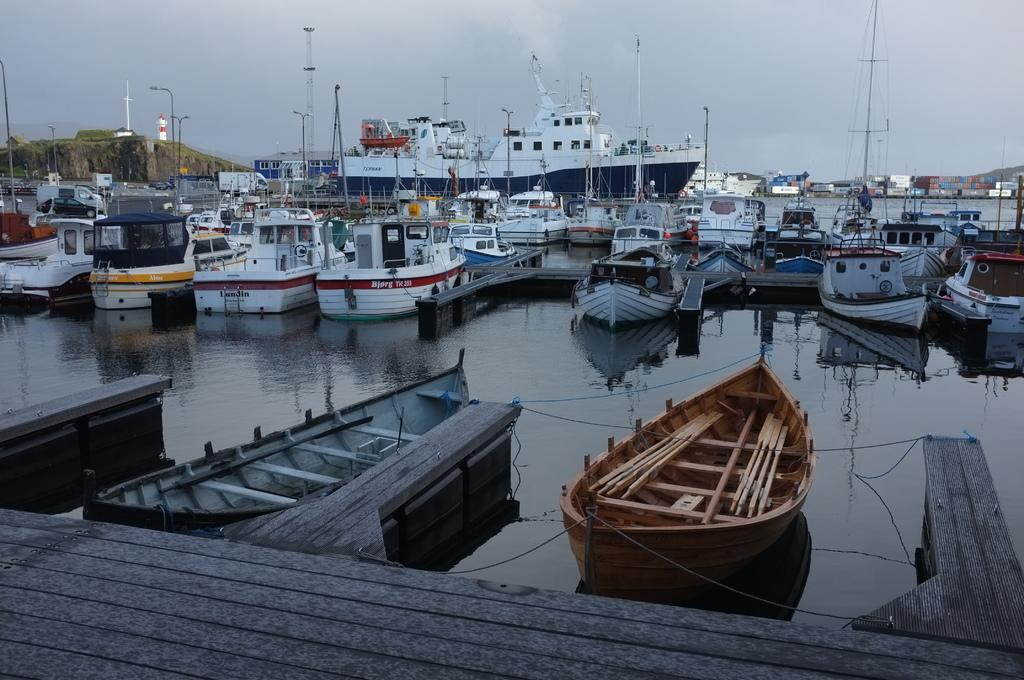What types of watercraft are visible in the image? There are ships and boats in the image. Where are the ships and boats located? They are on the surface of water in the image. What is the condition of the sky in the image? The sky is covered with clouds. What is at the bottom of the image? There is a wooden surface at the bottom of the image. How many hydrants can be seen near the boats in the image? There are no hydrants visible in the image; it features ships and boats on the water's surface. Are there any babies playing near the ships in the image? There is no indication of babies or any people in the image; it only shows ships and boats on the water's surface. 